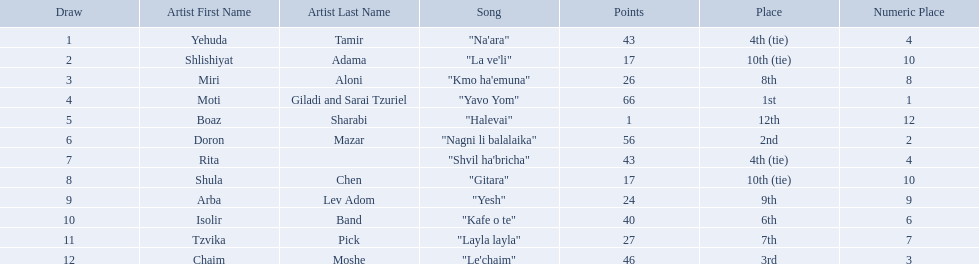How many artists are there? Yehuda Tamir, Shlishiyat Adama, Miri Aloni, Moti Giladi and Sarai Tzuriel, Boaz Sharabi, Doron Mazar, Rita, Shula Chen, Arba Lev Adom, Isolir Band, Tzvika Pick, Chaim Moshe. What is the least amount of points awarded? 1. Who was the artist awarded those points? Boaz Sharabi. What are the points in the competition? 43, 17, 26, 66, 1, 56, 43, 17, 24, 40, 27, 46. What is the lowest points? 1. What artist received these points? Boaz Sharabi. What is the place of the contestant who received only 1 point? 12th. What is the name of the artist listed in the previous question? Boaz Sharabi. 